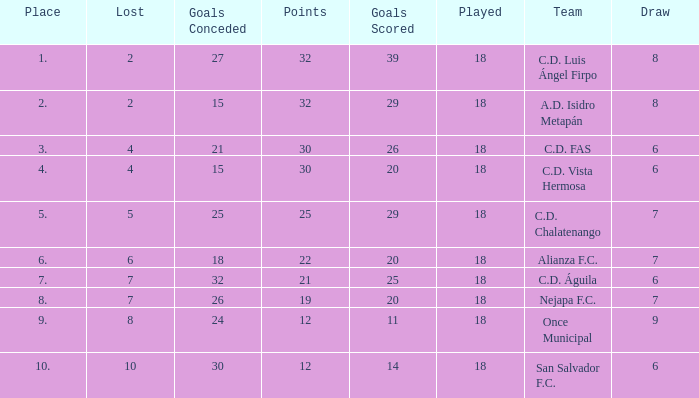What is the total number for a place with points smaller than 12? 0.0. 